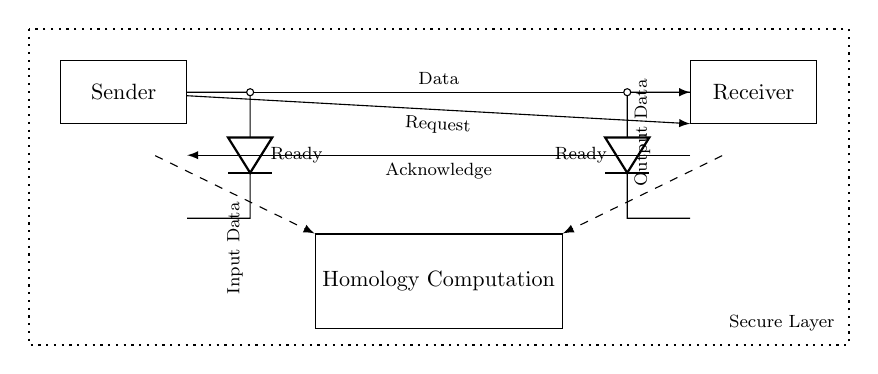What are the two main components in this circuit? The circuit contains a Sender and a Receiver, which are represented as rectangular blocks in the diagram.
Answer: Sender, Receiver What is the role of the 'Request' line in this circuit? The 'Request' line indicates that the Sender is asking the Receiver to prepare for data transfer, serving as the initiation of communication between the two components.
Answer: Initiation What type of protocol is illustrated in this circuit diagram? The circuit diagram implements an asynchronous protocol, as indicated by the separate request and acknowledge lines, which allow for data transfer without needing synchronized clocks between sender and receiver.
Answer: Asynchronous How does data flow from the Sender to the Homology Computation block? Data flows through a dashed line labeled 'Input Data' from the Sender's output to the Homology Computation block located below it, indicating that the computation processes this incoming data.
Answer: Dashed line What does the dotted rectangle in the diagram signify? The dotted rectangle represents the Security Layer, which encompasses both the Sender and Receiver to indicate that the data transfer is protected to ensure secure communication.
Answer: Secure Layer What is the function of the 'Acknowledge' line in this circuit? The 'Acknowledge' line allows the Receiver to signal back to the Sender that it has successfully received the data, completing the communication sequence required for secure data transfer.
Answer: Confirmation 